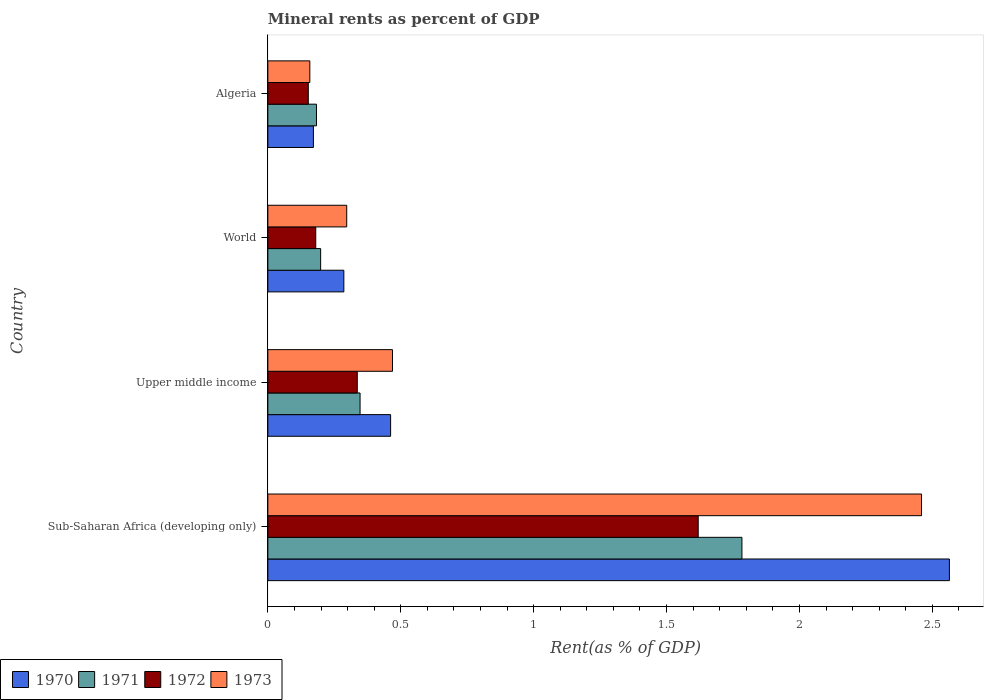How many groups of bars are there?
Provide a succinct answer. 4. Are the number of bars on each tick of the Y-axis equal?
Keep it short and to the point. Yes. How many bars are there on the 4th tick from the bottom?
Offer a very short reply. 4. What is the label of the 4th group of bars from the top?
Give a very brief answer. Sub-Saharan Africa (developing only). What is the mineral rent in 1972 in Algeria?
Offer a very short reply. 0.15. Across all countries, what is the maximum mineral rent in 1972?
Make the answer very short. 1.62. Across all countries, what is the minimum mineral rent in 1970?
Your answer should be very brief. 0.17. In which country was the mineral rent in 1972 maximum?
Give a very brief answer. Sub-Saharan Africa (developing only). In which country was the mineral rent in 1972 minimum?
Give a very brief answer. Algeria. What is the total mineral rent in 1972 in the graph?
Offer a very short reply. 2.29. What is the difference between the mineral rent in 1972 in Sub-Saharan Africa (developing only) and that in World?
Offer a terse response. 1.44. What is the difference between the mineral rent in 1971 in Sub-Saharan Africa (developing only) and the mineral rent in 1973 in Upper middle income?
Your answer should be very brief. 1.31. What is the average mineral rent in 1970 per country?
Provide a succinct answer. 0.87. What is the difference between the mineral rent in 1970 and mineral rent in 1971 in Algeria?
Ensure brevity in your answer.  -0.01. In how many countries, is the mineral rent in 1971 greater than 0.7 %?
Provide a succinct answer. 1. What is the ratio of the mineral rent in 1970 in Algeria to that in Sub-Saharan Africa (developing only)?
Offer a terse response. 0.07. Is the mineral rent in 1970 in Sub-Saharan Africa (developing only) less than that in Upper middle income?
Ensure brevity in your answer.  No. Is the difference between the mineral rent in 1970 in Algeria and Sub-Saharan Africa (developing only) greater than the difference between the mineral rent in 1971 in Algeria and Sub-Saharan Africa (developing only)?
Provide a succinct answer. No. What is the difference between the highest and the second highest mineral rent in 1973?
Your response must be concise. 1.99. What is the difference between the highest and the lowest mineral rent in 1972?
Ensure brevity in your answer.  1.47. Is the sum of the mineral rent in 1970 in Upper middle income and World greater than the maximum mineral rent in 1972 across all countries?
Your answer should be compact. No. Is it the case that in every country, the sum of the mineral rent in 1973 and mineral rent in 1971 is greater than the sum of mineral rent in 1970 and mineral rent in 1972?
Offer a very short reply. No. What does the 2nd bar from the bottom in Algeria represents?
Provide a succinct answer. 1971. Is it the case that in every country, the sum of the mineral rent in 1970 and mineral rent in 1971 is greater than the mineral rent in 1973?
Your response must be concise. Yes. How many bars are there?
Your answer should be compact. 16. Does the graph contain grids?
Provide a succinct answer. No. How many legend labels are there?
Ensure brevity in your answer.  4. What is the title of the graph?
Ensure brevity in your answer.  Mineral rents as percent of GDP. Does "1960" appear as one of the legend labels in the graph?
Your answer should be compact. No. What is the label or title of the X-axis?
Ensure brevity in your answer.  Rent(as % of GDP). What is the Rent(as % of GDP) in 1970 in Sub-Saharan Africa (developing only)?
Your answer should be compact. 2.56. What is the Rent(as % of GDP) of 1971 in Sub-Saharan Africa (developing only)?
Your response must be concise. 1.78. What is the Rent(as % of GDP) of 1972 in Sub-Saharan Africa (developing only)?
Your answer should be very brief. 1.62. What is the Rent(as % of GDP) in 1973 in Sub-Saharan Africa (developing only)?
Offer a terse response. 2.46. What is the Rent(as % of GDP) of 1970 in Upper middle income?
Your answer should be compact. 0.46. What is the Rent(as % of GDP) of 1971 in Upper middle income?
Give a very brief answer. 0.35. What is the Rent(as % of GDP) of 1972 in Upper middle income?
Ensure brevity in your answer.  0.34. What is the Rent(as % of GDP) of 1973 in Upper middle income?
Provide a succinct answer. 0.47. What is the Rent(as % of GDP) of 1970 in World?
Give a very brief answer. 0.29. What is the Rent(as % of GDP) of 1971 in World?
Give a very brief answer. 0.2. What is the Rent(as % of GDP) in 1972 in World?
Provide a short and direct response. 0.18. What is the Rent(as % of GDP) of 1973 in World?
Make the answer very short. 0.3. What is the Rent(as % of GDP) of 1970 in Algeria?
Make the answer very short. 0.17. What is the Rent(as % of GDP) in 1971 in Algeria?
Offer a terse response. 0.18. What is the Rent(as % of GDP) in 1972 in Algeria?
Give a very brief answer. 0.15. What is the Rent(as % of GDP) of 1973 in Algeria?
Provide a succinct answer. 0.16. Across all countries, what is the maximum Rent(as % of GDP) of 1970?
Offer a very short reply. 2.56. Across all countries, what is the maximum Rent(as % of GDP) in 1971?
Offer a terse response. 1.78. Across all countries, what is the maximum Rent(as % of GDP) of 1972?
Your answer should be compact. 1.62. Across all countries, what is the maximum Rent(as % of GDP) in 1973?
Offer a very short reply. 2.46. Across all countries, what is the minimum Rent(as % of GDP) in 1970?
Give a very brief answer. 0.17. Across all countries, what is the minimum Rent(as % of GDP) of 1971?
Ensure brevity in your answer.  0.18. Across all countries, what is the minimum Rent(as % of GDP) of 1972?
Keep it short and to the point. 0.15. Across all countries, what is the minimum Rent(as % of GDP) of 1973?
Keep it short and to the point. 0.16. What is the total Rent(as % of GDP) in 1970 in the graph?
Offer a terse response. 3.48. What is the total Rent(as % of GDP) of 1971 in the graph?
Provide a short and direct response. 2.51. What is the total Rent(as % of GDP) of 1972 in the graph?
Provide a succinct answer. 2.29. What is the total Rent(as % of GDP) in 1973 in the graph?
Provide a short and direct response. 3.38. What is the difference between the Rent(as % of GDP) of 1970 in Sub-Saharan Africa (developing only) and that in Upper middle income?
Make the answer very short. 2.1. What is the difference between the Rent(as % of GDP) in 1971 in Sub-Saharan Africa (developing only) and that in Upper middle income?
Keep it short and to the point. 1.44. What is the difference between the Rent(as % of GDP) in 1972 in Sub-Saharan Africa (developing only) and that in Upper middle income?
Give a very brief answer. 1.28. What is the difference between the Rent(as % of GDP) of 1973 in Sub-Saharan Africa (developing only) and that in Upper middle income?
Make the answer very short. 1.99. What is the difference between the Rent(as % of GDP) of 1970 in Sub-Saharan Africa (developing only) and that in World?
Your response must be concise. 2.28. What is the difference between the Rent(as % of GDP) in 1971 in Sub-Saharan Africa (developing only) and that in World?
Your answer should be very brief. 1.58. What is the difference between the Rent(as % of GDP) in 1972 in Sub-Saharan Africa (developing only) and that in World?
Provide a short and direct response. 1.44. What is the difference between the Rent(as % of GDP) in 1973 in Sub-Saharan Africa (developing only) and that in World?
Your answer should be very brief. 2.16. What is the difference between the Rent(as % of GDP) of 1970 in Sub-Saharan Africa (developing only) and that in Algeria?
Make the answer very short. 2.39. What is the difference between the Rent(as % of GDP) in 1971 in Sub-Saharan Africa (developing only) and that in Algeria?
Provide a short and direct response. 1.6. What is the difference between the Rent(as % of GDP) of 1972 in Sub-Saharan Africa (developing only) and that in Algeria?
Offer a terse response. 1.47. What is the difference between the Rent(as % of GDP) of 1973 in Sub-Saharan Africa (developing only) and that in Algeria?
Give a very brief answer. 2.3. What is the difference between the Rent(as % of GDP) in 1970 in Upper middle income and that in World?
Give a very brief answer. 0.18. What is the difference between the Rent(as % of GDP) in 1971 in Upper middle income and that in World?
Offer a very short reply. 0.15. What is the difference between the Rent(as % of GDP) of 1972 in Upper middle income and that in World?
Give a very brief answer. 0.16. What is the difference between the Rent(as % of GDP) of 1973 in Upper middle income and that in World?
Provide a short and direct response. 0.17. What is the difference between the Rent(as % of GDP) of 1970 in Upper middle income and that in Algeria?
Give a very brief answer. 0.29. What is the difference between the Rent(as % of GDP) of 1971 in Upper middle income and that in Algeria?
Keep it short and to the point. 0.16. What is the difference between the Rent(as % of GDP) in 1972 in Upper middle income and that in Algeria?
Provide a short and direct response. 0.18. What is the difference between the Rent(as % of GDP) of 1973 in Upper middle income and that in Algeria?
Offer a very short reply. 0.31. What is the difference between the Rent(as % of GDP) in 1970 in World and that in Algeria?
Your answer should be compact. 0.11. What is the difference between the Rent(as % of GDP) in 1971 in World and that in Algeria?
Your response must be concise. 0.02. What is the difference between the Rent(as % of GDP) of 1972 in World and that in Algeria?
Make the answer very short. 0.03. What is the difference between the Rent(as % of GDP) in 1973 in World and that in Algeria?
Provide a short and direct response. 0.14. What is the difference between the Rent(as % of GDP) of 1970 in Sub-Saharan Africa (developing only) and the Rent(as % of GDP) of 1971 in Upper middle income?
Offer a very short reply. 2.22. What is the difference between the Rent(as % of GDP) in 1970 in Sub-Saharan Africa (developing only) and the Rent(as % of GDP) in 1972 in Upper middle income?
Offer a terse response. 2.23. What is the difference between the Rent(as % of GDP) in 1970 in Sub-Saharan Africa (developing only) and the Rent(as % of GDP) in 1973 in Upper middle income?
Offer a terse response. 2.1. What is the difference between the Rent(as % of GDP) in 1971 in Sub-Saharan Africa (developing only) and the Rent(as % of GDP) in 1972 in Upper middle income?
Provide a short and direct response. 1.45. What is the difference between the Rent(as % of GDP) of 1971 in Sub-Saharan Africa (developing only) and the Rent(as % of GDP) of 1973 in Upper middle income?
Make the answer very short. 1.31. What is the difference between the Rent(as % of GDP) in 1972 in Sub-Saharan Africa (developing only) and the Rent(as % of GDP) in 1973 in Upper middle income?
Your answer should be very brief. 1.15. What is the difference between the Rent(as % of GDP) in 1970 in Sub-Saharan Africa (developing only) and the Rent(as % of GDP) in 1971 in World?
Give a very brief answer. 2.37. What is the difference between the Rent(as % of GDP) in 1970 in Sub-Saharan Africa (developing only) and the Rent(as % of GDP) in 1972 in World?
Your answer should be very brief. 2.38. What is the difference between the Rent(as % of GDP) in 1970 in Sub-Saharan Africa (developing only) and the Rent(as % of GDP) in 1973 in World?
Provide a succinct answer. 2.27. What is the difference between the Rent(as % of GDP) of 1971 in Sub-Saharan Africa (developing only) and the Rent(as % of GDP) of 1972 in World?
Your answer should be very brief. 1.6. What is the difference between the Rent(as % of GDP) of 1971 in Sub-Saharan Africa (developing only) and the Rent(as % of GDP) of 1973 in World?
Your answer should be very brief. 1.49. What is the difference between the Rent(as % of GDP) in 1972 in Sub-Saharan Africa (developing only) and the Rent(as % of GDP) in 1973 in World?
Offer a terse response. 1.32. What is the difference between the Rent(as % of GDP) of 1970 in Sub-Saharan Africa (developing only) and the Rent(as % of GDP) of 1971 in Algeria?
Keep it short and to the point. 2.38. What is the difference between the Rent(as % of GDP) in 1970 in Sub-Saharan Africa (developing only) and the Rent(as % of GDP) in 1972 in Algeria?
Give a very brief answer. 2.41. What is the difference between the Rent(as % of GDP) in 1970 in Sub-Saharan Africa (developing only) and the Rent(as % of GDP) in 1973 in Algeria?
Your answer should be very brief. 2.41. What is the difference between the Rent(as % of GDP) in 1971 in Sub-Saharan Africa (developing only) and the Rent(as % of GDP) in 1972 in Algeria?
Keep it short and to the point. 1.63. What is the difference between the Rent(as % of GDP) of 1971 in Sub-Saharan Africa (developing only) and the Rent(as % of GDP) of 1973 in Algeria?
Offer a very short reply. 1.63. What is the difference between the Rent(as % of GDP) of 1972 in Sub-Saharan Africa (developing only) and the Rent(as % of GDP) of 1973 in Algeria?
Your answer should be very brief. 1.46. What is the difference between the Rent(as % of GDP) in 1970 in Upper middle income and the Rent(as % of GDP) in 1971 in World?
Ensure brevity in your answer.  0.26. What is the difference between the Rent(as % of GDP) of 1970 in Upper middle income and the Rent(as % of GDP) of 1972 in World?
Offer a terse response. 0.28. What is the difference between the Rent(as % of GDP) in 1970 in Upper middle income and the Rent(as % of GDP) in 1973 in World?
Give a very brief answer. 0.17. What is the difference between the Rent(as % of GDP) of 1971 in Upper middle income and the Rent(as % of GDP) of 1972 in World?
Your answer should be compact. 0.17. What is the difference between the Rent(as % of GDP) of 1971 in Upper middle income and the Rent(as % of GDP) of 1973 in World?
Offer a terse response. 0.05. What is the difference between the Rent(as % of GDP) in 1972 in Upper middle income and the Rent(as % of GDP) in 1973 in World?
Keep it short and to the point. 0.04. What is the difference between the Rent(as % of GDP) of 1970 in Upper middle income and the Rent(as % of GDP) of 1971 in Algeria?
Provide a succinct answer. 0.28. What is the difference between the Rent(as % of GDP) of 1970 in Upper middle income and the Rent(as % of GDP) of 1972 in Algeria?
Your answer should be compact. 0.31. What is the difference between the Rent(as % of GDP) of 1970 in Upper middle income and the Rent(as % of GDP) of 1973 in Algeria?
Your answer should be compact. 0.3. What is the difference between the Rent(as % of GDP) in 1971 in Upper middle income and the Rent(as % of GDP) in 1972 in Algeria?
Give a very brief answer. 0.19. What is the difference between the Rent(as % of GDP) in 1971 in Upper middle income and the Rent(as % of GDP) in 1973 in Algeria?
Provide a short and direct response. 0.19. What is the difference between the Rent(as % of GDP) of 1972 in Upper middle income and the Rent(as % of GDP) of 1973 in Algeria?
Ensure brevity in your answer.  0.18. What is the difference between the Rent(as % of GDP) in 1970 in World and the Rent(as % of GDP) in 1971 in Algeria?
Provide a succinct answer. 0.1. What is the difference between the Rent(as % of GDP) in 1970 in World and the Rent(as % of GDP) in 1972 in Algeria?
Your answer should be very brief. 0.13. What is the difference between the Rent(as % of GDP) of 1970 in World and the Rent(as % of GDP) of 1973 in Algeria?
Your answer should be very brief. 0.13. What is the difference between the Rent(as % of GDP) of 1971 in World and the Rent(as % of GDP) of 1972 in Algeria?
Offer a terse response. 0.05. What is the difference between the Rent(as % of GDP) in 1971 in World and the Rent(as % of GDP) in 1973 in Algeria?
Your answer should be very brief. 0.04. What is the difference between the Rent(as % of GDP) in 1972 in World and the Rent(as % of GDP) in 1973 in Algeria?
Ensure brevity in your answer.  0.02. What is the average Rent(as % of GDP) in 1970 per country?
Ensure brevity in your answer.  0.87. What is the average Rent(as % of GDP) in 1971 per country?
Provide a succinct answer. 0.63. What is the average Rent(as % of GDP) in 1972 per country?
Ensure brevity in your answer.  0.57. What is the average Rent(as % of GDP) of 1973 per country?
Ensure brevity in your answer.  0.85. What is the difference between the Rent(as % of GDP) in 1970 and Rent(as % of GDP) in 1971 in Sub-Saharan Africa (developing only)?
Your answer should be compact. 0.78. What is the difference between the Rent(as % of GDP) of 1970 and Rent(as % of GDP) of 1972 in Sub-Saharan Africa (developing only)?
Provide a short and direct response. 0.95. What is the difference between the Rent(as % of GDP) in 1970 and Rent(as % of GDP) in 1973 in Sub-Saharan Africa (developing only)?
Your answer should be very brief. 0.1. What is the difference between the Rent(as % of GDP) of 1971 and Rent(as % of GDP) of 1972 in Sub-Saharan Africa (developing only)?
Your response must be concise. 0.16. What is the difference between the Rent(as % of GDP) of 1971 and Rent(as % of GDP) of 1973 in Sub-Saharan Africa (developing only)?
Offer a very short reply. -0.68. What is the difference between the Rent(as % of GDP) in 1972 and Rent(as % of GDP) in 1973 in Sub-Saharan Africa (developing only)?
Offer a very short reply. -0.84. What is the difference between the Rent(as % of GDP) of 1970 and Rent(as % of GDP) of 1971 in Upper middle income?
Provide a short and direct response. 0.11. What is the difference between the Rent(as % of GDP) of 1970 and Rent(as % of GDP) of 1972 in Upper middle income?
Provide a succinct answer. 0.13. What is the difference between the Rent(as % of GDP) of 1970 and Rent(as % of GDP) of 1973 in Upper middle income?
Offer a terse response. -0.01. What is the difference between the Rent(as % of GDP) in 1971 and Rent(as % of GDP) in 1972 in Upper middle income?
Your answer should be very brief. 0.01. What is the difference between the Rent(as % of GDP) in 1971 and Rent(as % of GDP) in 1973 in Upper middle income?
Keep it short and to the point. -0.12. What is the difference between the Rent(as % of GDP) in 1972 and Rent(as % of GDP) in 1973 in Upper middle income?
Offer a terse response. -0.13. What is the difference between the Rent(as % of GDP) of 1970 and Rent(as % of GDP) of 1971 in World?
Offer a terse response. 0.09. What is the difference between the Rent(as % of GDP) of 1970 and Rent(as % of GDP) of 1972 in World?
Keep it short and to the point. 0.11. What is the difference between the Rent(as % of GDP) in 1970 and Rent(as % of GDP) in 1973 in World?
Provide a succinct answer. -0.01. What is the difference between the Rent(as % of GDP) of 1971 and Rent(as % of GDP) of 1972 in World?
Your answer should be very brief. 0.02. What is the difference between the Rent(as % of GDP) in 1971 and Rent(as % of GDP) in 1973 in World?
Provide a short and direct response. -0.1. What is the difference between the Rent(as % of GDP) in 1972 and Rent(as % of GDP) in 1973 in World?
Offer a terse response. -0.12. What is the difference between the Rent(as % of GDP) in 1970 and Rent(as % of GDP) in 1971 in Algeria?
Give a very brief answer. -0.01. What is the difference between the Rent(as % of GDP) of 1970 and Rent(as % of GDP) of 1972 in Algeria?
Your response must be concise. 0.02. What is the difference between the Rent(as % of GDP) of 1970 and Rent(as % of GDP) of 1973 in Algeria?
Provide a short and direct response. 0.01. What is the difference between the Rent(as % of GDP) in 1971 and Rent(as % of GDP) in 1972 in Algeria?
Your response must be concise. 0.03. What is the difference between the Rent(as % of GDP) in 1971 and Rent(as % of GDP) in 1973 in Algeria?
Offer a very short reply. 0.03. What is the difference between the Rent(as % of GDP) of 1972 and Rent(as % of GDP) of 1973 in Algeria?
Your response must be concise. -0.01. What is the ratio of the Rent(as % of GDP) of 1970 in Sub-Saharan Africa (developing only) to that in Upper middle income?
Keep it short and to the point. 5.55. What is the ratio of the Rent(as % of GDP) of 1971 in Sub-Saharan Africa (developing only) to that in Upper middle income?
Your response must be concise. 5.14. What is the ratio of the Rent(as % of GDP) in 1972 in Sub-Saharan Africa (developing only) to that in Upper middle income?
Make the answer very short. 4.81. What is the ratio of the Rent(as % of GDP) in 1973 in Sub-Saharan Africa (developing only) to that in Upper middle income?
Your response must be concise. 5.24. What is the ratio of the Rent(as % of GDP) of 1970 in Sub-Saharan Africa (developing only) to that in World?
Provide a short and direct response. 8.97. What is the ratio of the Rent(as % of GDP) in 1971 in Sub-Saharan Africa (developing only) to that in World?
Ensure brevity in your answer.  8.98. What is the ratio of the Rent(as % of GDP) of 1972 in Sub-Saharan Africa (developing only) to that in World?
Keep it short and to the point. 8.98. What is the ratio of the Rent(as % of GDP) in 1973 in Sub-Saharan Africa (developing only) to that in World?
Make the answer very short. 8.29. What is the ratio of the Rent(as % of GDP) in 1970 in Sub-Saharan Africa (developing only) to that in Algeria?
Give a very brief answer. 14.96. What is the ratio of the Rent(as % of GDP) of 1971 in Sub-Saharan Africa (developing only) to that in Algeria?
Offer a very short reply. 9.75. What is the ratio of the Rent(as % of GDP) of 1972 in Sub-Saharan Africa (developing only) to that in Algeria?
Ensure brevity in your answer.  10.64. What is the ratio of the Rent(as % of GDP) in 1973 in Sub-Saharan Africa (developing only) to that in Algeria?
Your response must be concise. 15.57. What is the ratio of the Rent(as % of GDP) of 1970 in Upper middle income to that in World?
Your answer should be very brief. 1.62. What is the ratio of the Rent(as % of GDP) in 1971 in Upper middle income to that in World?
Give a very brief answer. 1.75. What is the ratio of the Rent(as % of GDP) in 1972 in Upper middle income to that in World?
Give a very brief answer. 1.87. What is the ratio of the Rent(as % of GDP) in 1973 in Upper middle income to that in World?
Offer a terse response. 1.58. What is the ratio of the Rent(as % of GDP) in 1970 in Upper middle income to that in Algeria?
Give a very brief answer. 2.69. What is the ratio of the Rent(as % of GDP) of 1971 in Upper middle income to that in Algeria?
Provide a short and direct response. 1.9. What is the ratio of the Rent(as % of GDP) in 1972 in Upper middle income to that in Algeria?
Ensure brevity in your answer.  2.21. What is the ratio of the Rent(as % of GDP) of 1973 in Upper middle income to that in Algeria?
Ensure brevity in your answer.  2.97. What is the ratio of the Rent(as % of GDP) of 1970 in World to that in Algeria?
Offer a terse response. 1.67. What is the ratio of the Rent(as % of GDP) in 1971 in World to that in Algeria?
Your answer should be compact. 1.09. What is the ratio of the Rent(as % of GDP) of 1972 in World to that in Algeria?
Ensure brevity in your answer.  1.18. What is the ratio of the Rent(as % of GDP) of 1973 in World to that in Algeria?
Your response must be concise. 1.88. What is the difference between the highest and the second highest Rent(as % of GDP) of 1970?
Make the answer very short. 2.1. What is the difference between the highest and the second highest Rent(as % of GDP) of 1971?
Give a very brief answer. 1.44. What is the difference between the highest and the second highest Rent(as % of GDP) in 1972?
Keep it short and to the point. 1.28. What is the difference between the highest and the second highest Rent(as % of GDP) of 1973?
Keep it short and to the point. 1.99. What is the difference between the highest and the lowest Rent(as % of GDP) of 1970?
Offer a terse response. 2.39. What is the difference between the highest and the lowest Rent(as % of GDP) in 1971?
Ensure brevity in your answer.  1.6. What is the difference between the highest and the lowest Rent(as % of GDP) of 1972?
Your response must be concise. 1.47. What is the difference between the highest and the lowest Rent(as % of GDP) of 1973?
Ensure brevity in your answer.  2.3. 